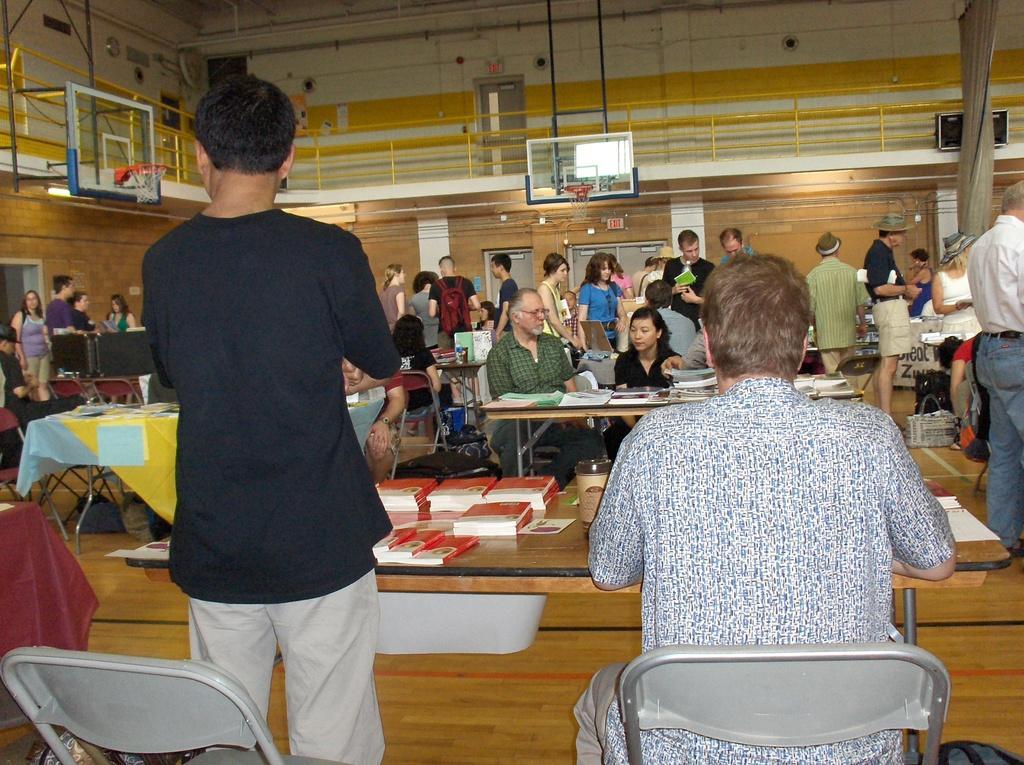Can you describe this image briefly? Most of the persons are standing and few persons are sitting on chairs. We can able to see tables, on this table there are books, bottle and cloth. On floor there are bags. On top there is a basketball net. These are speakers. 